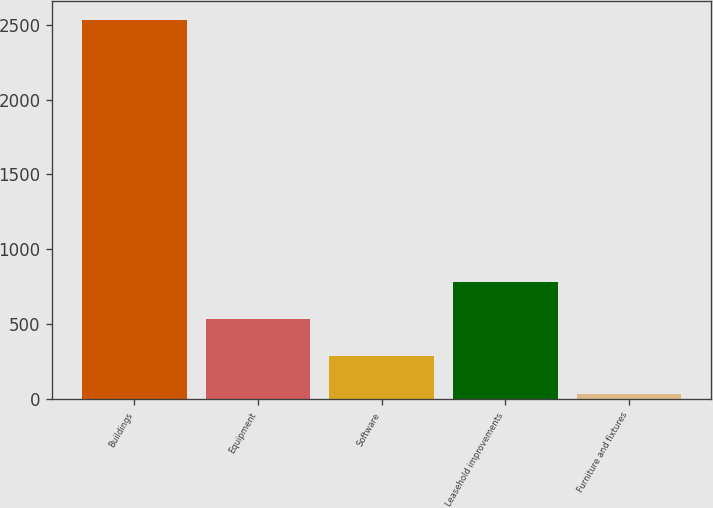Convert chart. <chart><loc_0><loc_0><loc_500><loc_500><bar_chart><fcel>Buildings<fcel>Equipment<fcel>Software<fcel>Leasehold improvements<fcel>Furniture and fixtures<nl><fcel>2530<fcel>535.6<fcel>286.3<fcel>784.9<fcel>37<nl></chart> 